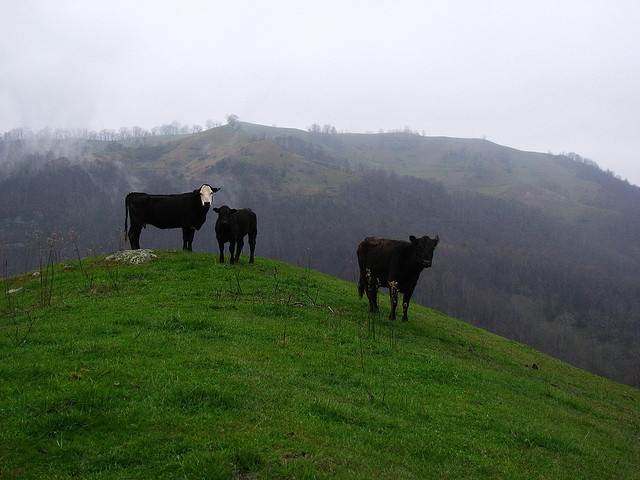Describe the objects in this image and their specific colors. I can see cow in lavender, black, gray, and darkgreen tones, cow in lavender, black, gray, darkgray, and tan tones, and cow in lavender, black, gray, and darkgreen tones in this image. 